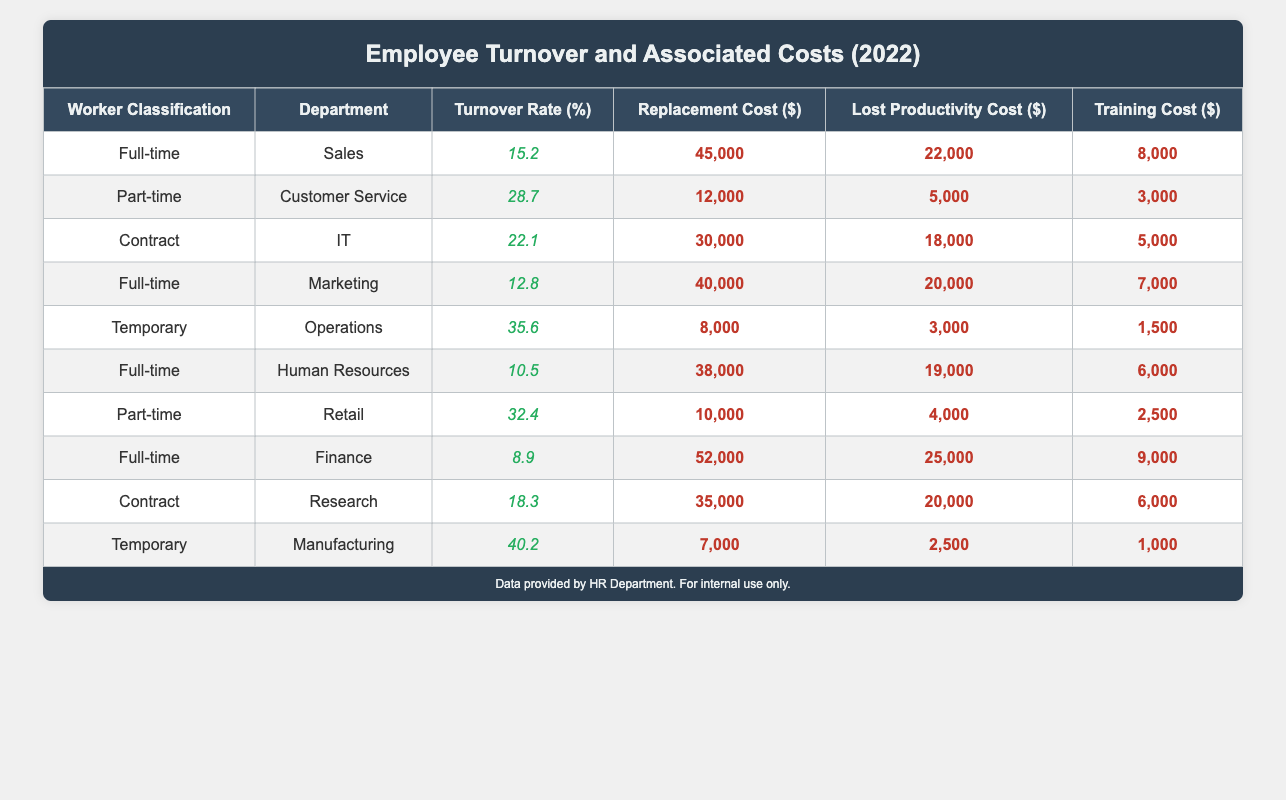What is the turnover rate for full-time workers in the Sales department? From the table, we can find that the turnover rate for full-time workers in the Sales department is listed as 15.2%.
Answer: 15.2% What is the total replacement cost for part-time workers in both Customer Service and Retail? To find the total replacement cost for part-time workers, we add the replacement costs from both departments: 12,000 (Customer Service) + 10,000 (Retail) = 22,000.
Answer: 22,000 Is the turnover rate for temporary workers higher than that for part-time workers? The turnover rate for temporary workers is 40.2%, while for part-time workers, the maximum rate listed is 32.4%. Since 40.2% is greater than 32.4%, the statement is true.
Answer: Yes What are the lost productivity costs for the Contract workers in IT and Research combined? The lost productivity costs for the Contract workers are 18,000 (IT) + 20,000 (Research) = 38,000. Therefore, the combined lost productivity costs from both departments is 38,000.
Answer: 38,000 What is the average training cost for full-time workers across all departments? The training costs for the full-time workers are 8,000 (Sales) + 7,000 (Marketing) + 6,000 (Human Resources) + 9,000 (Finance) = 30,000. There are 4 data points, so we divide total training costs by 4: 30,000 / 4 = 7,500.
Answer: 7,500 Does any worker classification in the table have a turnover rate below 10%? Referring to the table, the only worker classification with a turnover rate below 10% is Full-time workers in the Finance department at 8.9%. Thus, the answer is yes.
Answer: Yes Which department has the highest replacement cost for temporary workers? Looking at the table, the replacement cost for temporary workers in the Manufacturing department is 7,000, while in Operations, it is 8,000. The Operations department has the highest replacement cost for temporary workers.
Answer: Operations What is the difference in turnover rates between full-time and part-time workers? The average turnover rate for full-time workers can be calculated by taking the average of their rates: (15.2 + 12.8 + 10.5 + 8.9) / 4 = 11.85%. The average turnover rate for part-time workers is (28.7 + 32.4) / 2 = 30.55%. The difference is 30.55 - 11.85 = 18.70%.
Answer: 18.70% 